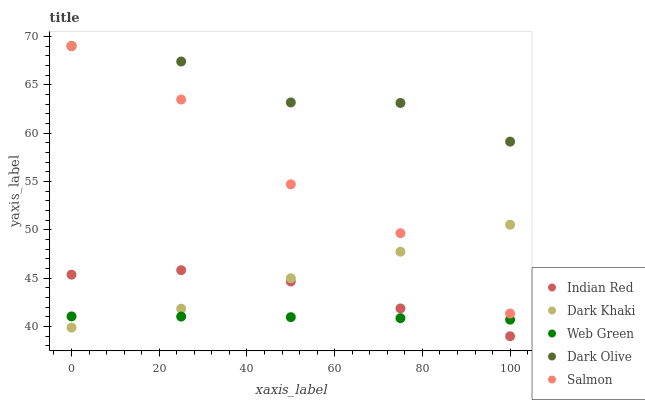Does Web Green have the minimum area under the curve?
Answer yes or no. Yes. Does Dark Olive have the maximum area under the curve?
Answer yes or no. Yes. Does Salmon have the minimum area under the curve?
Answer yes or no. No. Does Salmon have the maximum area under the curve?
Answer yes or no. No. Is Web Green the smoothest?
Answer yes or no. Yes. Is Dark Olive the roughest?
Answer yes or no. Yes. Is Salmon the smoothest?
Answer yes or no. No. Is Salmon the roughest?
Answer yes or no. No. Does Indian Red have the lowest value?
Answer yes or no. Yes. Does Salmon have the lowest value?
Answer yes or no. No. Does Salmon have the highest value?
Answer yes or no. Yes. Does Web Green have the highest value?
Answer yes or no. No. Is Indian Red less than Salmon?
Answer yes or no. Yes. Is Salmon greater than Web Green?
Answer yes or no. Yes. Does Dark Khaki intersect Web Green?
Answer yes or no. Yes. Is Dark Khaki less than Web Green?
Answer yes or no. No. Is Dark Khaki greater than Web Green?
Answer yes or no. No. Does Indian Red intersect Salmon?
Answer yes or no. No. 